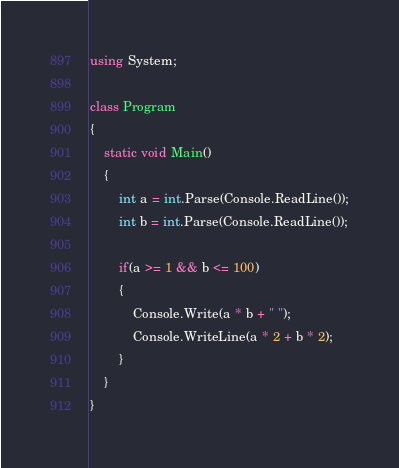<code> <loc_0><loc_0><loc_500><loc_500><_C#_>using System;

class Program
{
    static void Main()
    {
        int a = int.Parse(Console.ReadLine());
        int b = int.Parse(Console.ReadLine());

        if(a >= 1 && b <= 100)
        {
            Console.Write(a * b + " ");
            Console.WriteLine(a * 2 + b * 2);
        }
    }
}</code> 